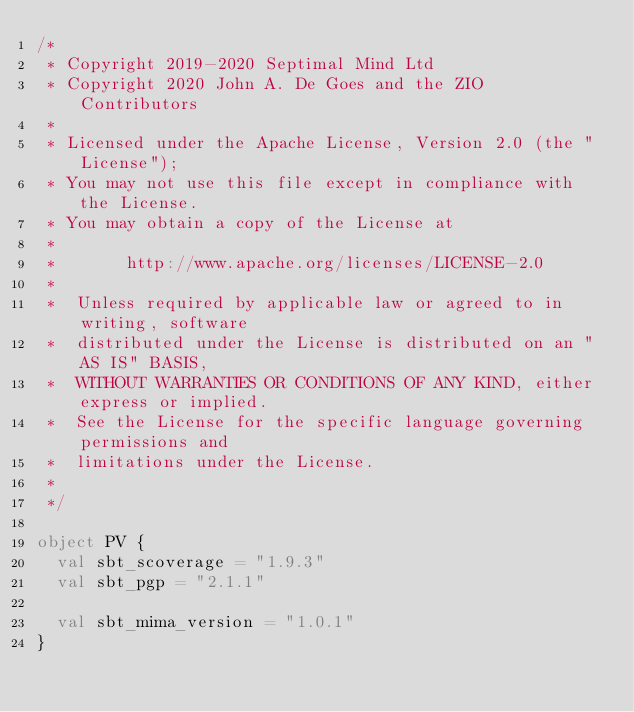Convert code to text. <code><loc_0><loc_0><loc_500><loc_500><_Scala_>/*
 * Copyright 2019-2020 Septimal Mind Ltd
 * Copyright 2020 John A. De Goes and the ZIO Contributors
 *
 * Licensed under the Apache License, Version 2.0 (the "License");
 * You may not use this file except in compliance with the License.
 * You may obtain a copy of the License at
 *
 *       http://www.apache.org/licenses/LICENSE-2.0
 *
 *  Unless required by applicable law or agreed to in writing, software
 *  distributed under the License is distributed on an "AS IS" BASIS,
 *  WITHOUT WARRANTIES OR CONDITIONS OF ANY KIND, either express or implied.
 *  See the License for the specific language governing permissions and
 *  limitations under the License.
 *
 */

object PV {
  val sbt_scoverage = "1.9.3"
  val sbt_pgp = "2.1.1"

  val sbt_mima_version = "1.0.1"
}
</code> 